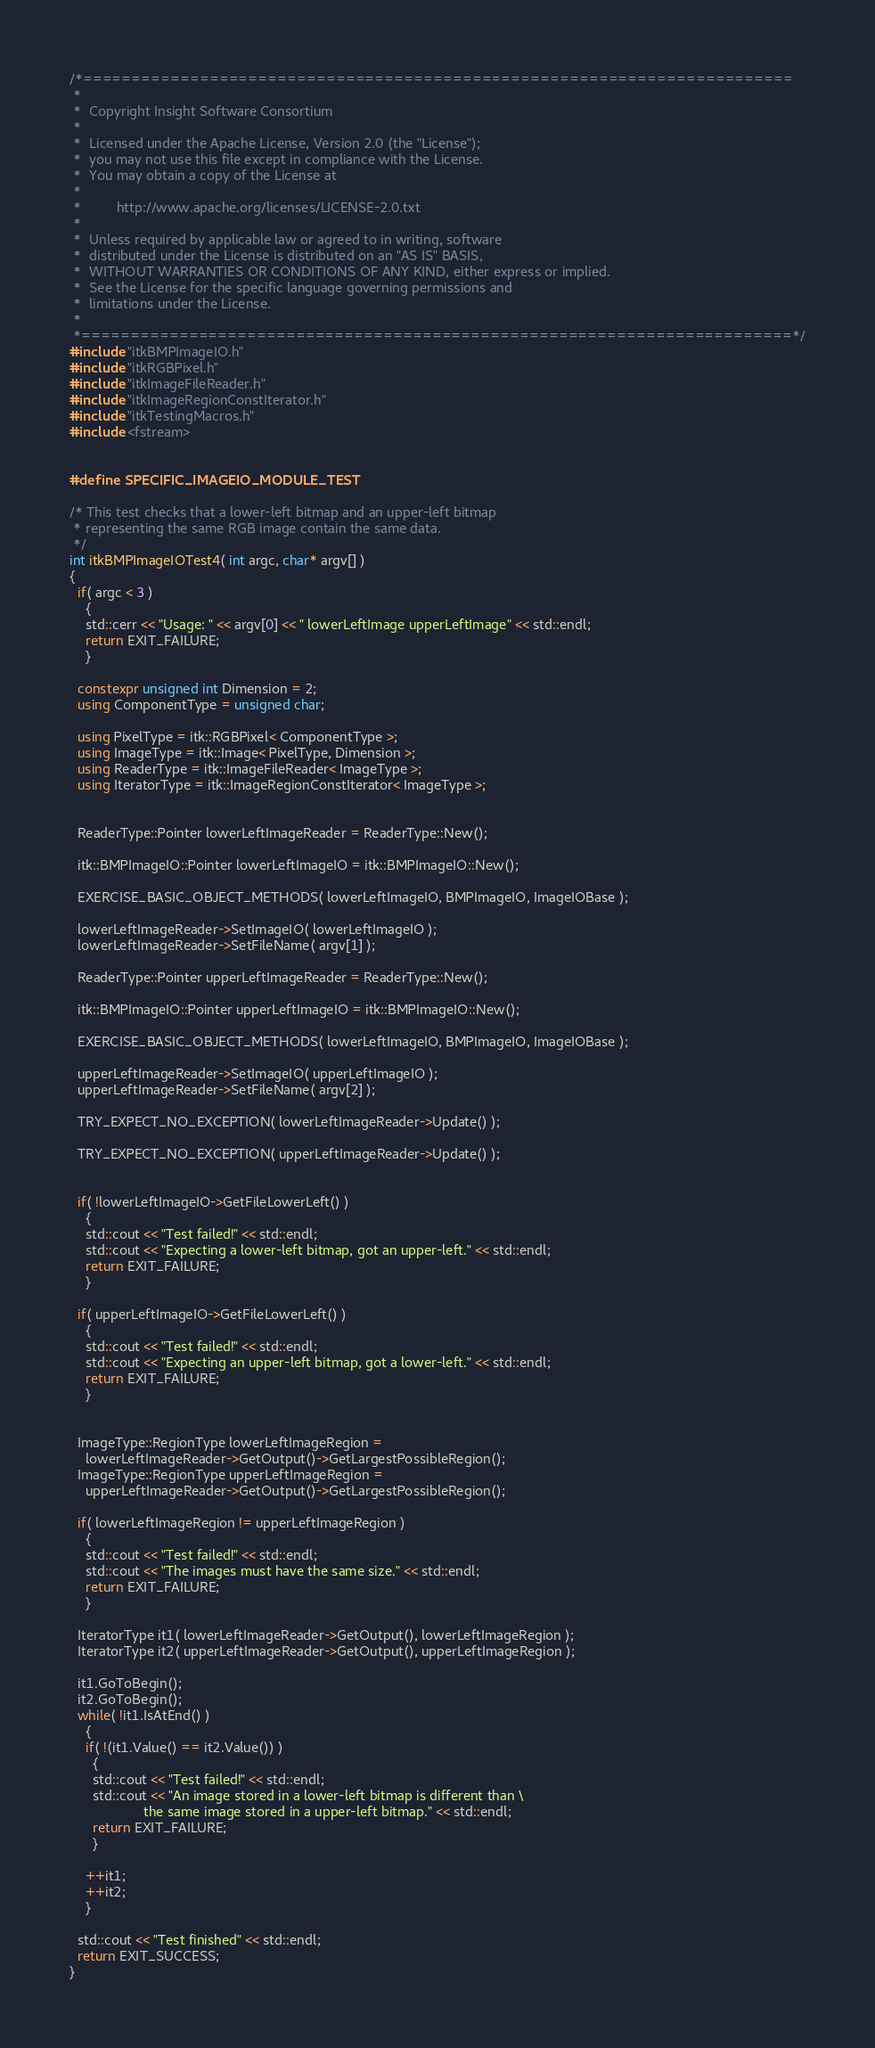Convert code to text. <code><loc_0><loc_0><loc_500><loc_500><_C++_>/*=========================================================================
 *
 *  Copyright Insight Software Consortium
 *
 *  Licensed under the Apache License, Version 2.0 (the "License");
 *  you may not use this file except in compliance with the License.
 *  You may obtain a copy of the License at
 *
 *         http://www.apache.org/licenses/LICENSE-2.0.txt
 *
 *  Unless required by applicable law or agreed to in writing, software
 *  distributed under the License is distributed on an "AS IS" BASIS,
 *  WITHOUT WARRANTIES OR CONDITIONS OF ANY KIND, either express or implied.
 *  See the License for the specific language governing permissions and
 *  limitations under the License.
 *
 *=========================================================================*/
#include "itkBMPImageIO.h"
#include "itkRGBPixel.h"
#include "itkImageFileReader.h"
#include "itkImageRegionConstIterator.h"
#include "itkTestingMacros.h"
#include <fstream>


#define SPECIFIC_IMAGEIO_MODULE_TEST

/* This test checks that a lower-left bitmap and an upper-left bitmap
 * representing the same RGB image contain the same data.
 */
int itkBMPImageIOTest4( int argc, char* argv[] )
{
  if( argc < 3 )
    {
    std::cerr << "Usage: " << argv[0] << " lowerLeftImage upperLeftImage" << std::endl;
    return EXIT_FAILURE;
    }

  constexpr unsigned int Dimension = 2;
  using ComponentType = unsigned char;

  using PixelType = itk::RGBPixel< ComponentType >;
  using ImageType = itk::Image< PixelType, Dimension >;
  using ReaderType = itk::ImageFileReader< ImageType >;
  using IteratorType = itk::ImageRegionConstIterator< ImageType >;


  ReaderType::Pointer lowerLeftImageReader = ReaderType::New();

  itk::BMPImageIO::Pointer lowerLeftImageIO = itk::BMPImageIO::New();

  EXERCISE_BASIC_OBJECT_METHODS( lowerLeftImageIO, BMPImageIO, ImageIOBase );

  lowerLeftImageReader->SetImageIO( lowerLeftImageIO );
  lowerLeftImageReader->SetFileName( argv[1] );

  ReaderType::Pointer upperLeftImageReader = ReaderType::New();

  itk::BMPImageIO::Pointer upperLeftImageIO = itk::BMPImageIO::New();

  EXERCISE_BASIC_OBJECT_METHODS( lowerLeftImageIO, BMPImageIO, ImageIOBase );

  upperLeftImageReader->SetImageIO( upperLeftImageIO );
  upperLeftImageReader->SetFileName( argv[2] );

  TRY_EXPECT_NO_EXCEPTION( lowerLeftImageReader->Update() );

  TRY_EXPECT_NO_EXCEPTION( upperLeftImageReader->Update() );


  if( !lowerLeftImageIO->GetFileLowerLeft() )
    {
    std::cout << "Test failed!" << std::endl;
    std::cout << "Expecting a lower-left bitmap, got an upper-left." << std::endl;
    return EXIT_FAILURE;
    }

  if( upperLeftImageIO->GetFileLowerLeft() )
    {
    std::cout << "Test failed!" << std::endl;
    std::cout << "Expecting an upper-left bitmap, got a lower-left." << std::endl;
    return EXIT_FAILURE;
    }


  ImageType::RegionType lowerLeftImageRegion =
    lowerLeftImageReader->GetOutput()->GetLargestPossibleRegion();
  ImageType::RegionType upperLeftImageRegion =
    upperLeftImageReader->GetOutput()->GetLargestPossibleRegion();

  if( lowerLeftImageRegion != upperLeftImageRegion )
    {
    std::cout << "Test failed!" << std::endl;
    std::cout << "The images must have the same size." << std::endl;
    return EXIT_FAILURE;
    }

  IteratorType it1( lowerLeftImageReader->GetOutput(), lowerLeftImageRegion );
  IteratorType it2( upperLeftImageReader->GetOutput(), upperLeftImageRegion );

  it1.GoToBegin();
  it2.GoToBegin();
  while( !it1.IsAtEnd() )
    {
    if( !(it1.Value() == it2.Value()) )
      {
      std::cout << "Test failed!" << std::endl;
      std::cout << "An image stored in a lower-left bitmap is different than \
                   the same image stored in a upper-left bitmap." << std::endl;
      return EXIT_FAILURE;
      }

    ++it1;
    ++it2;
    }

  std::cout << "Test finished" << std::endl;
  return EXIT_SUCCESS;
}
</code> 